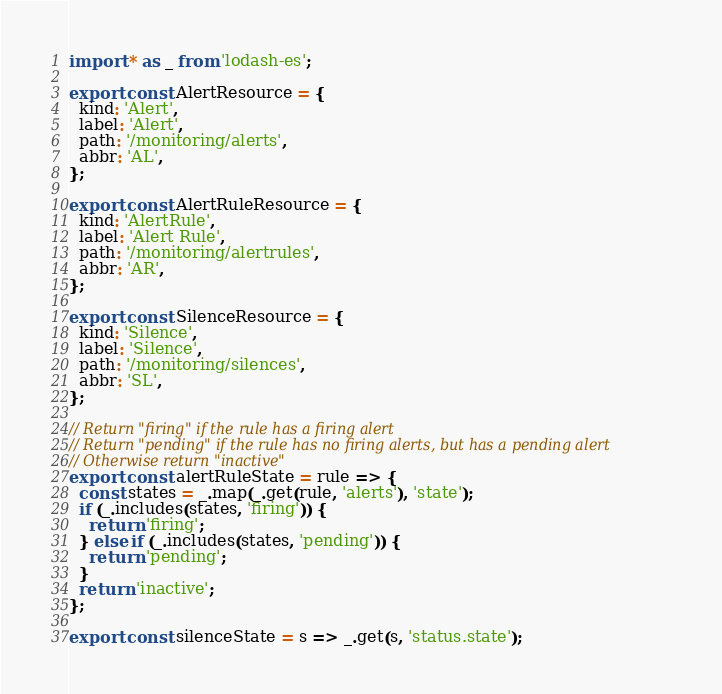<code> <loc_0><loc_0><loc_500><loc_500><_JavaScript_>import * as _ from 'lodash-es';

export const AlertResource = {
  kind: 'Alert',
  label: 'Alert',
  path: '/monitoring/alerts',
  abbr: 'AL',
};

export const AlertRuleResource = {
  kind: 'AlertRule',
  label: 'Alert Rule',
  path: '/monitoring/alertrules',
  abbr: 'AR',
};

export const SilenceResource = {
  kind: 'Silence',
  label: 'Silence',
  path: '/monitoring/silences',
  abbr: 'SL',
};

// Return "firing" if the rule has a firing alert
// Return "pending" if the rule has no firing alerts, but has a pending alert
// Otherwise return "inactive"
export const alertRuleState = rule => {
  const states = _.map(_.get(rule, 'alerts'), 'state');
  if (_.includes(states, 'firing')) {
    return 'firing';
  } else if (_.includes(states, 'pending')) {
    return 'pending';
  }
  return 'inactive';
};

export const silenceState = s => _.get(s, 'status.state');
</code> 